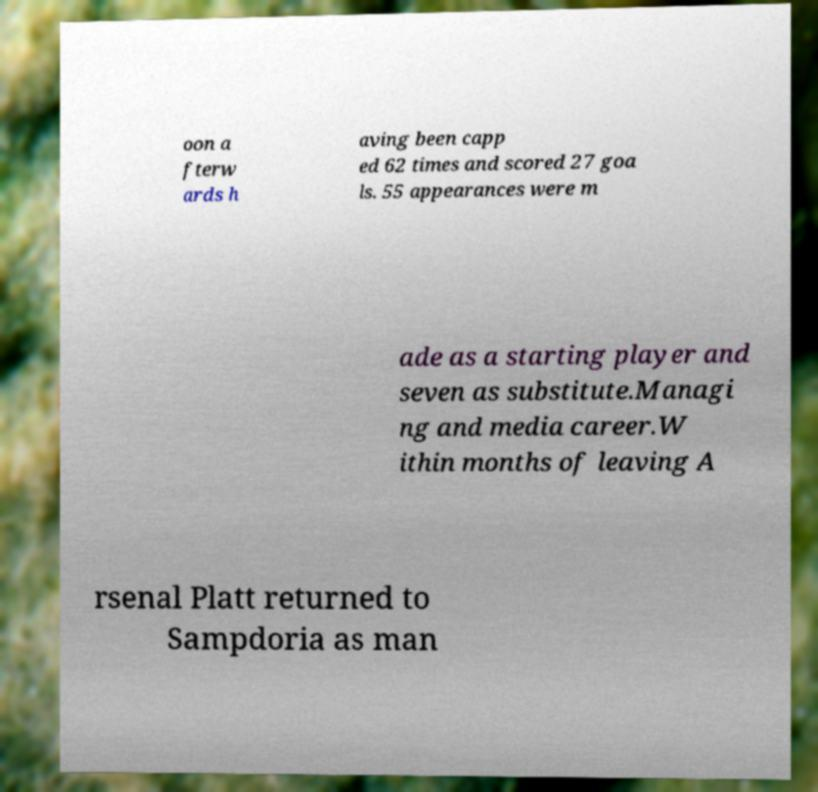For documentation purposes, I need the text within this image transcribed. Could you provide that? oon a fterw ards h aving been capp ed 62 times and scored 27 goa ls. 55 appearances were m ade as a starting player and seven as substitute.Managi ng and media career.W ithin months of leaving A rsenal Platt returned to Sampdoria as man 